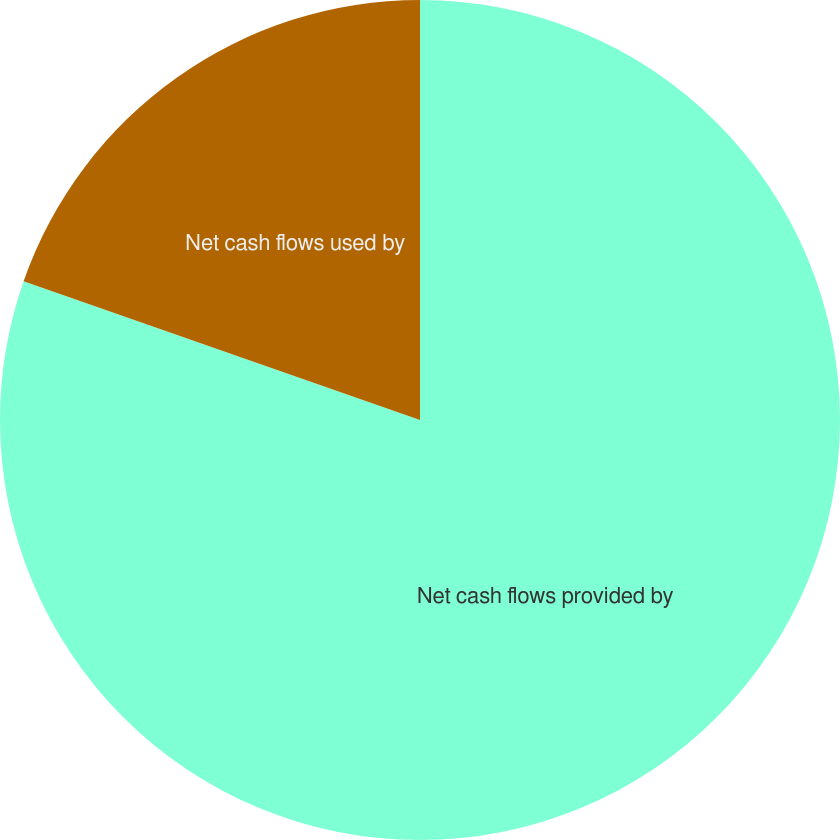Convert chart to OTSL. <chart><loc_0><loc_0><loc_500><loc_500><pie_chart><fcel>Net cash flows provided by<fcel>Net cash flows used by<nl><fcel>80.36%<fcel>19.64%<nl></chart> 